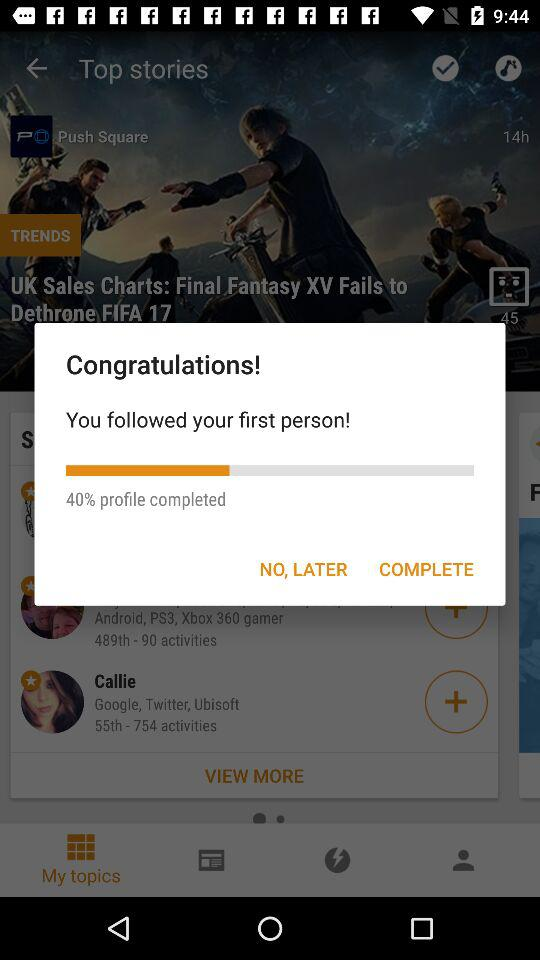How many percent of the profile is completed?
Answer the question using a single word or phrase. 40% 